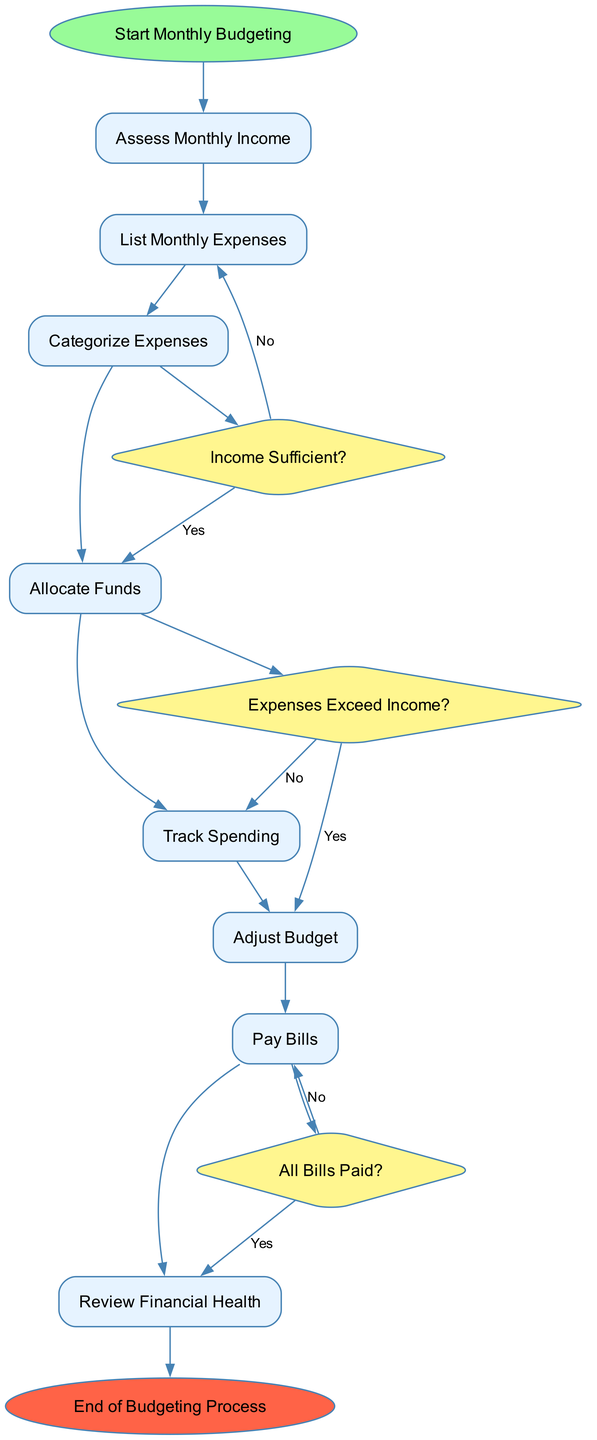What is the first activity in the budgeting process? The diagram starts with the "Start Monthly Budgeting" node, leading directly to the first activity, which is "Assess Monthly Income."
Answer: Assess Monthly Income How many activities are listed in the diagram? Counting the activities listed in the diagram, there are a total of eight activities enumerated before reaching decisions and the end node.
Answer: Eight Which decision follows the "Categorize Expenses" activity? After "Categorize Expenses," the flow leads to a decision node named "Income Sufficient?" indicating the next step in the process.
Answer: Income Sufficient? What happens if expenses exceed income? If total expenses exceed income (as indicated by the "Expenses Exceed Income?" decision node), the flow leads back to the "List Monthly Expenses" activity for reassessment.
Answer: List Monthly Expenses What is the last activity before the end of the budgeting process? The last activity in the flow before reaching the end node is "Review Financial Health," which evaluates the financial situation at the end of the month.
Answer: Review Financial Health If all bills are paid, which activity comes next? If the "All Bills Paid?" decision results in a "Yes," the flow continues directly to the "End of Budgeting Process" node, concluding the process.
Answer: End of Budgeting Process What activity involves monitoring actual spending? The activity dedicated to monitoring actual spending throughout the month is "Track Spending," which is key to adhering to the budget.
Answer: Track Spending What type of expenses does "Allocate Funds" focus on? "Allocate Funds" primarily aims at distributing income to cover all fixed and essential variable expenses, ensuring necessary costs are met first.
Answer: Fixed and essential variable expenses 